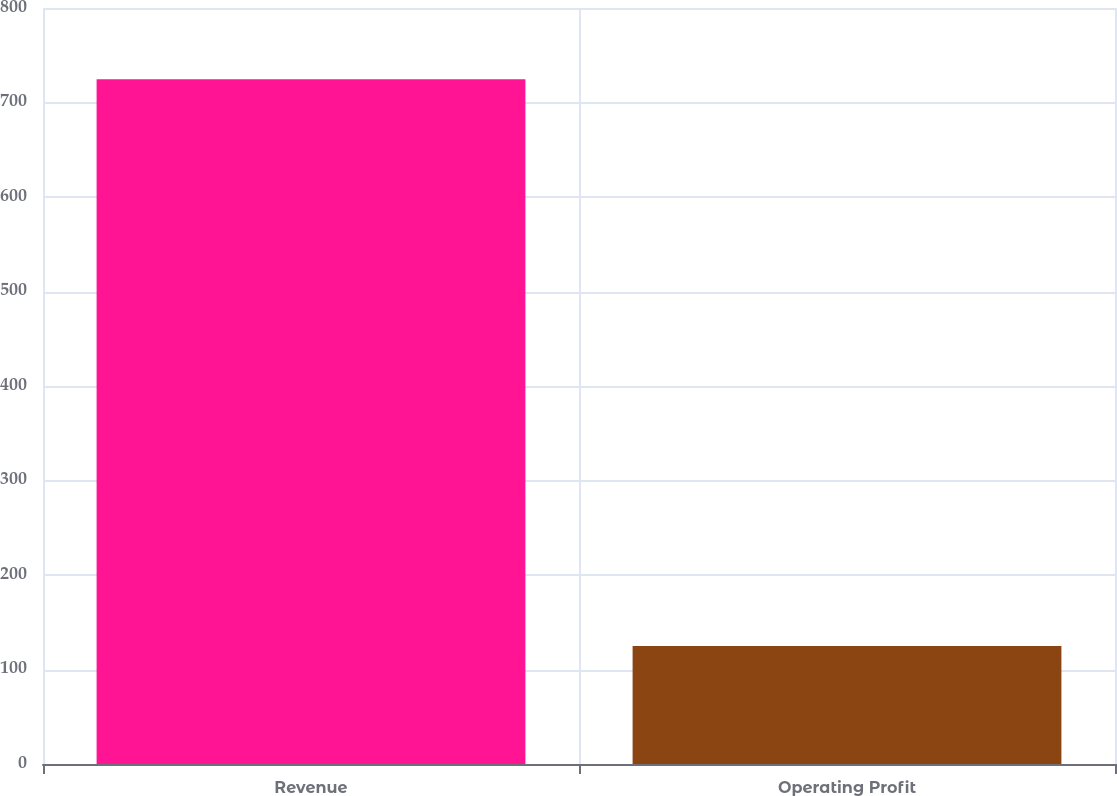Convert chart. <chart><loc_0><loc_0><loc_500><loc_500><bar_chart><fcel>Revenue<fcel>Operating Profit<nl><fcel>724.5<fcel>124.8<nl></chart> 